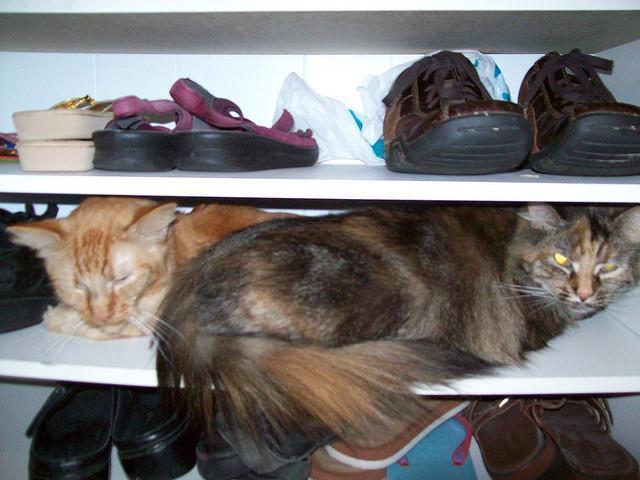How many cats are in the picture?
Give a very brief answer. 2. How many people in this image are dragging a suitcase behind them?
Give a very brief answer. 0. 